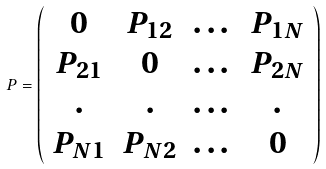Convert formula to latex. <formula><loc_0><loc_0><loc_500><loc_500>P = \left ( \begin{array} { c c c c } 0 & P _ { 1 2 } & \dots & P _ { 1 N } \\ P _ { 2 1 } & 0 & \dots & P _ { 2 N } \\ . & . & \dots & . \\ P _ { N 1 } & P _ { N 2 } & \dots & 0 \end{array} \right )</formula> 